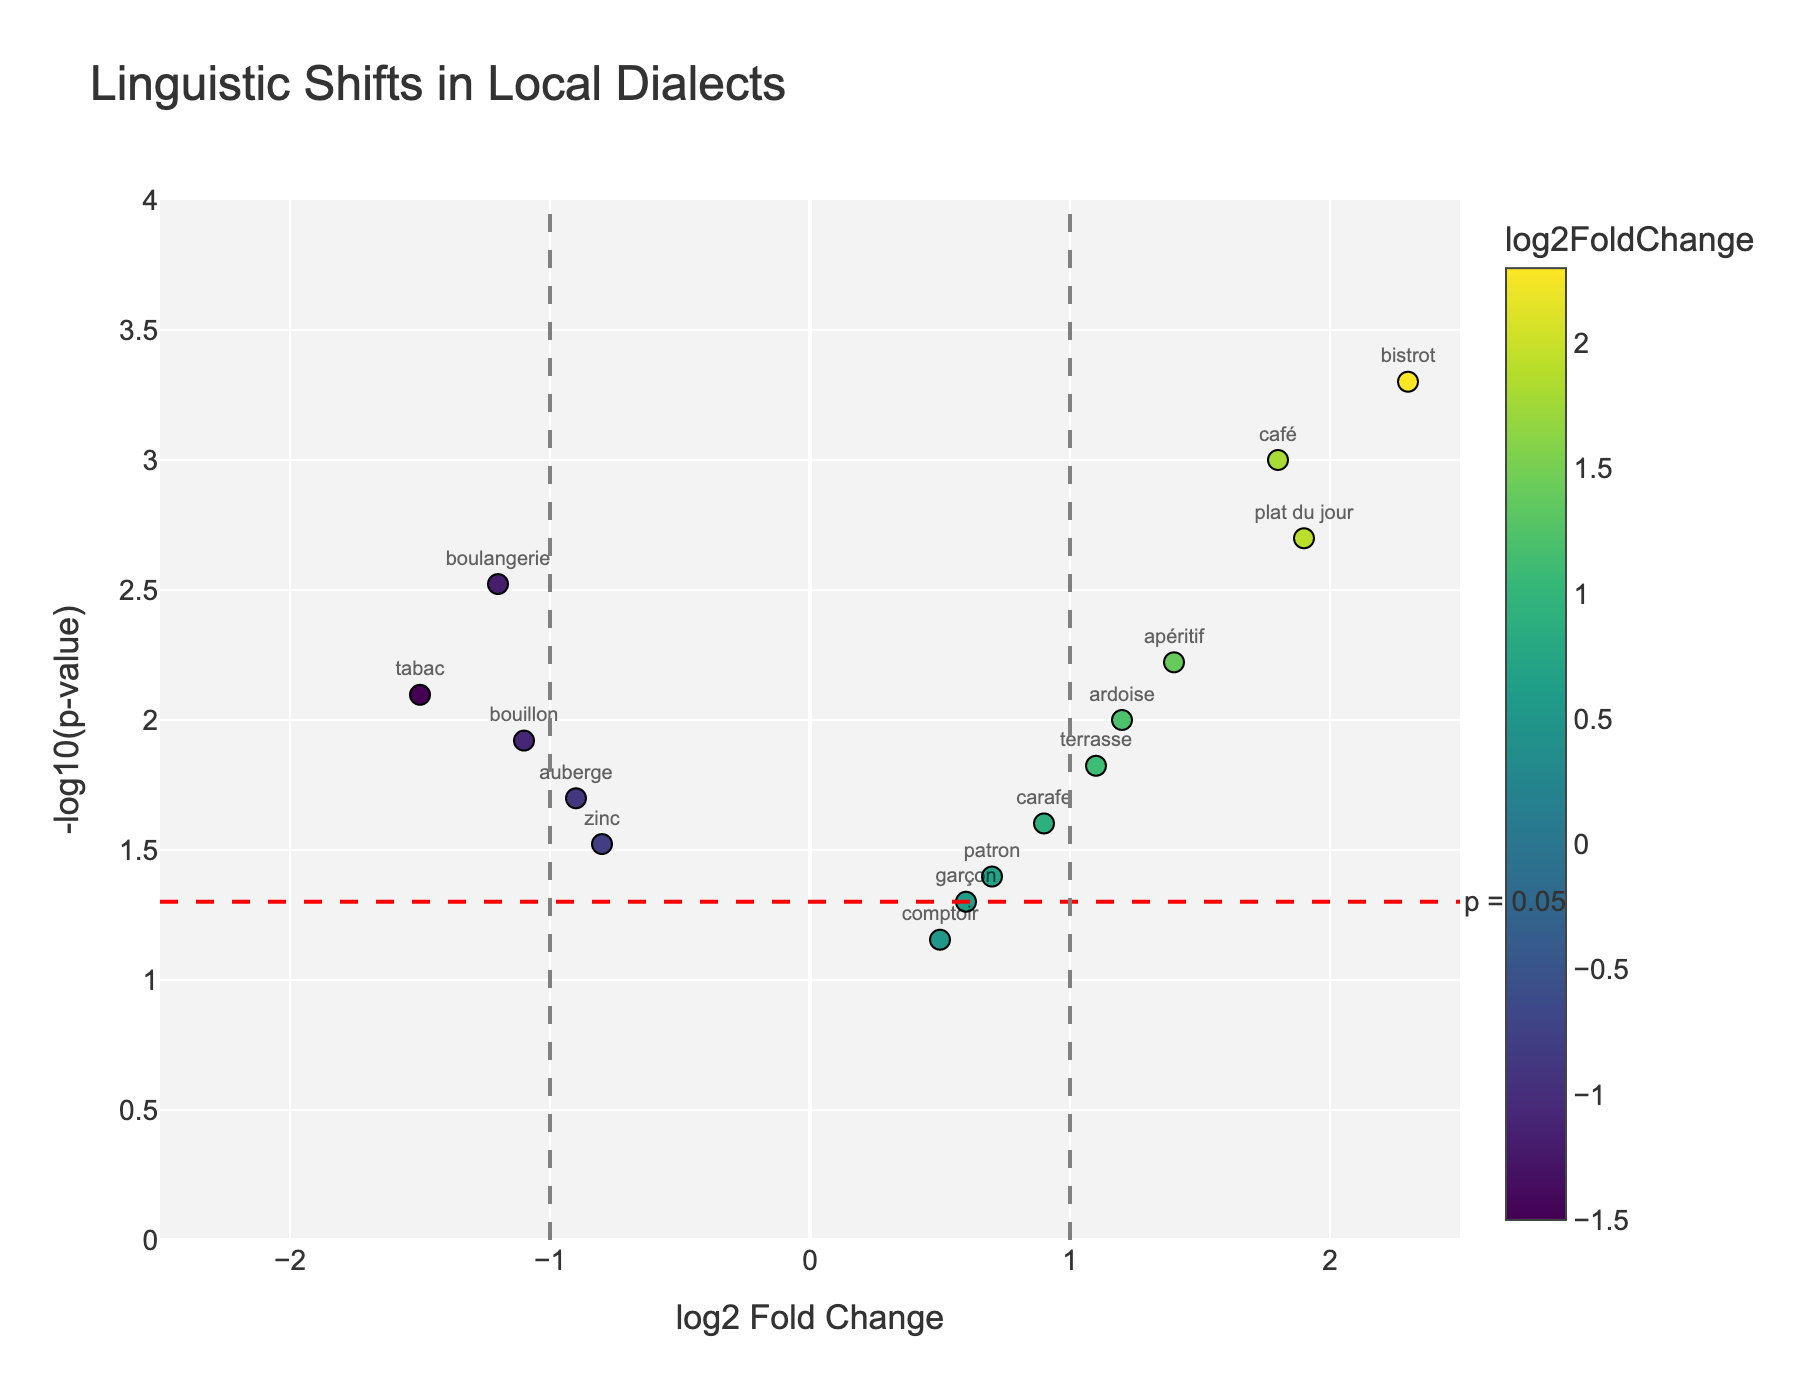How many data points have a -log10(p-value) greater than 2? Identify the y-axis (which represents -log10(p-value)) and count the number of points with a y-value above 2.
Answer: 8 Which word has the highest log2FoldChange? Look at the x-axis (log2FoldChange) and find the word with the highest x-value.
Answer: bistrot Which word has the lowest p-value? The lowest p-value corresponds to the highest -log10(p-value). Identify the point with the highest value on the y-axis and note the corresponding word.
Answer: bistrot Across the terms 'bistrot' and 'comptoir,' which has a more significant p-value? Compare their y-values: -log10(pValue) for both words. The one with the lower y-value has the more significant (larger) p-value.
Answer: comptoir How many words have a positive log2FoldChange and a -log10(p-value) greater than 1.3? First, identify the words with a positive log2FoldChange (right side of the plot) and then count those with a -log10(p-value) greater than 1.3 (above the horizontal line near 1.3).
Answer: 7 Which words fall below the significance threshold of p-value 0.05 and have negative log2FoldChange? Identify the points below the red-dashed horizontal line (indicating the p-value threshold) and to the left of the plot (negative log2FoldChange). Note the corresponding words.
Answer: boulangerie, auberge, tabac, zinc, bouillon Which words show the highest and lowest p-values, and what is their difference in log2FoldChange? Find the words with the highest and lowest y-values, then calculate the absolute difference of their x-values (log2FoldChange).
Answer: bistrot and comptoir, 1.8 Is the word 'apéritif' above or below the significance threshold, and what does this imply? Check the position of 'apéritif' relative to the horizontal red-dashed line (p-value 0.05 threshold). Above means below the threshold, implying significance.
Answer: above, significant What is the trend in log2FoldChange for the words 'boulangerie,' 'café,' and 'patron'? Examine the x-values for 'boulangerie' (negative), 'café' (positive), and 'patron' (positive) to determine their respective trends.
Answer: negative, positive, positive 